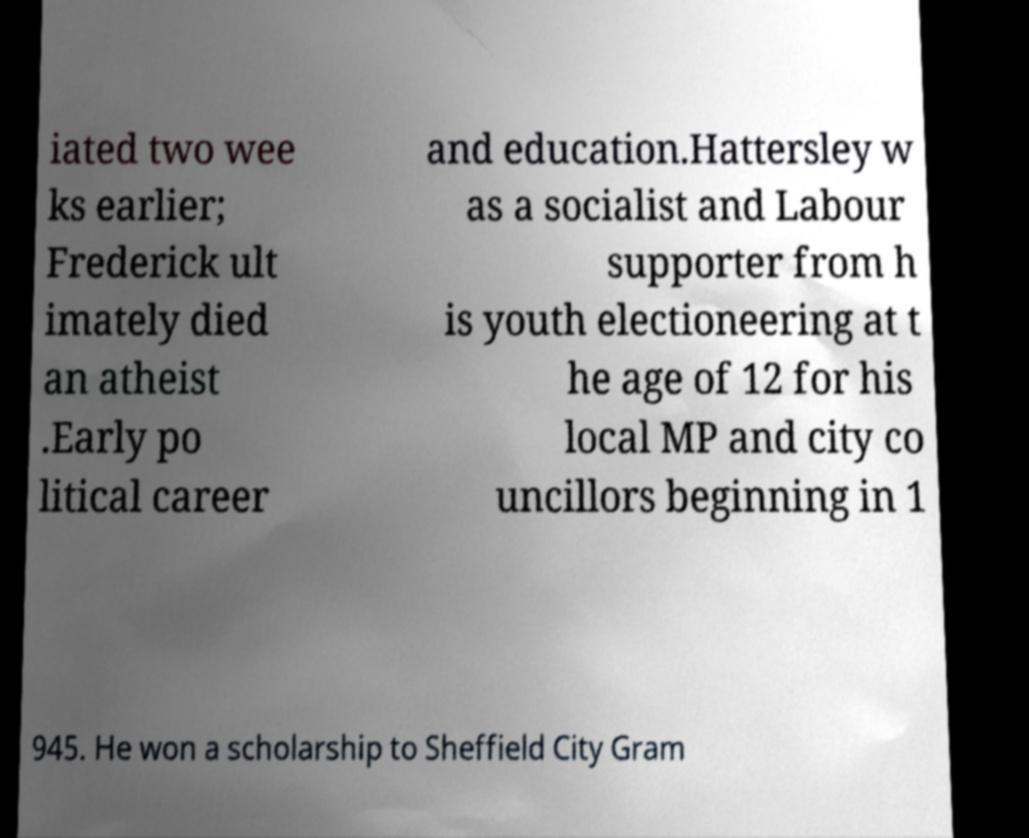There's text embedded in this image that I need extracted. Can you transcribe it verbatim? iated two wee ks earlier; Frederick ult imately died an atheist .Early po litical career and education.Hattersley w as a socialist and Labour supporter from h is youth electioneering at t he age of 12 for his local MP and city co uncillors beginning in 1 945. He won a scholarship to Sheffield City Gram 